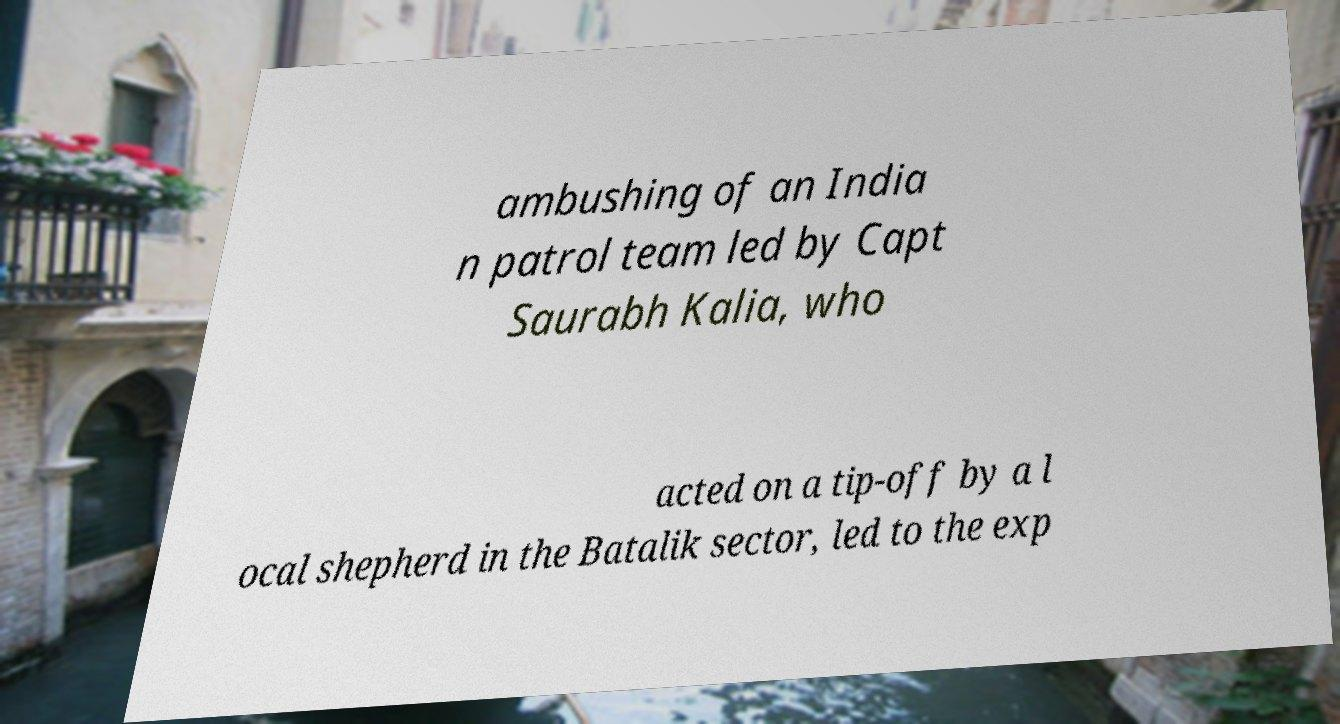There's text embedded in this image that I need extracted. Can you transcribe it verbatim? ambushing of an India n patrol team led by Capt Saurabh Kalia, who acted on a tip-off by a l ocal shepherd in the Batalik sector, led to the exp 